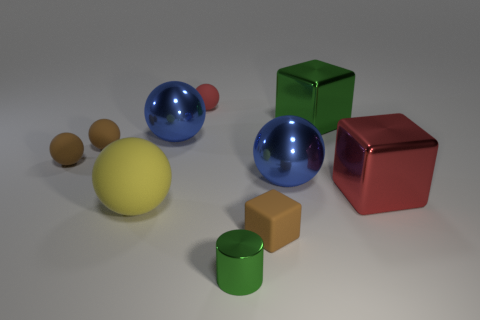What size is the metal thing that is both left of the brown block and on the right side of the small red object?
Offer a very short reply. Small. What number of other objects are there of the same shape as the yellow rubber object?
Keep it short and to the point. 5. What number of blocks are either matte objects or small red matte things?
Your response must be concise. 1. Are there any tiny metallic things that are left of the small brown object that is to the right of the small green object that is in front of the big matte sphere?
Provide a succinct answer. Yes. There is a tiny rubber thing that is the same shape as the large red metal object; what is its color?
Your answer should be very brief. Brown. How many red things are tiny blocks or tiny rubber spheres?
Your response must be concise. 1. What material is the green thing right of the green object in front of the large yellow rubber ball?
Ensure brevity in your answer.  Metal. Does the large green metallic thing have the same shape as the yellow rubber object?
Give a very brief answer. No. The cylinder that is the same size as the brown block is what color?
Your answer should be very brief. Green. Is there a shiny cylinder of the same color as the tiny metallic object?
Ensure brevity in your answer.  No. 